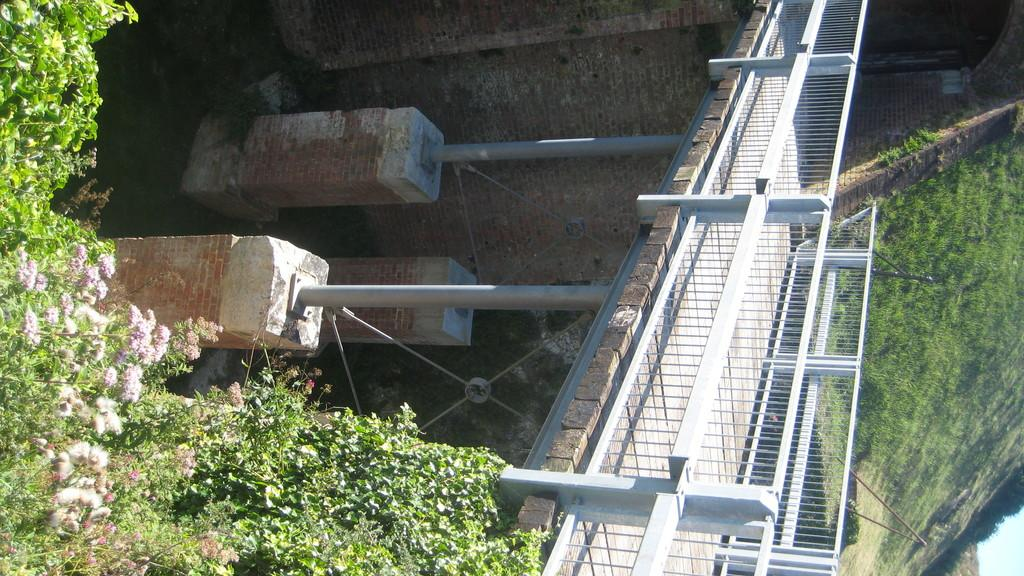What structure is located on the right side of the image? There is a bridge on the right side of the image. What feature does the bridge have? The bridge has a railing. What architectural elements can be seen in the image? There are pillars in the image. What type of vegetation is present in the image? There are plants with flowers and trees in the image. Can you tell me how many quinces are on the bridge in the image? There are no quinces present in the image; it features a bridge, pillars, plants with flowers, and trees. What type of vase is holding the flowers on the bridge in the image? There is no vase holding flowers on the bridge in the image; the flowers are growing on plants. 